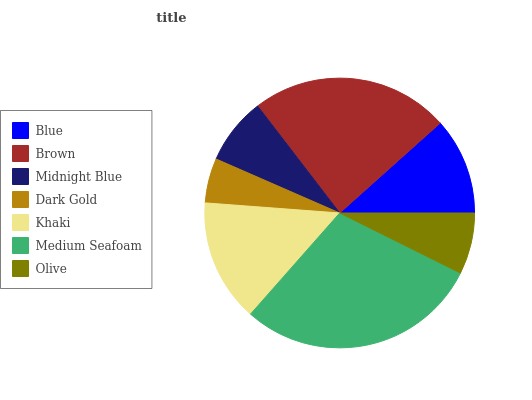Is Dark Gold the minimum?
Answer yes or no. Yes. Is Medium Seafoam the maximum?
Answer yes or no. Yes. Is Brown the minimum?
Answer yes or no. No. Is Brown the maximum?
Answer yes or no. No. Is Brown greater than Blue?
Answer yes or no. Yes. Is Blue less than Brown?
Answer yes or no. Yes. Is Blue greater than Brown?
Answer yes or no. No. Is Brown less than Blue?
Answer yes or no. No. Is Blue the high median?
Answer yes or no. Yes. Is Blue the low median?
Answer yes or no. Yes. Is Olive the high median?
Answer yes or no. No. Is Olive the low median?
Answer yes or no. No. 